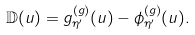<formula> <loc_0><loc_0><loc_500><loc_500>\mathbb { D } ( u ) = g _ { \eta ^ { \prime } } ^ { ( g ) } ( u ) - \phi _ { \eta ^ { \prime } } ^ { ( g ) } ( u ) .</formula> 